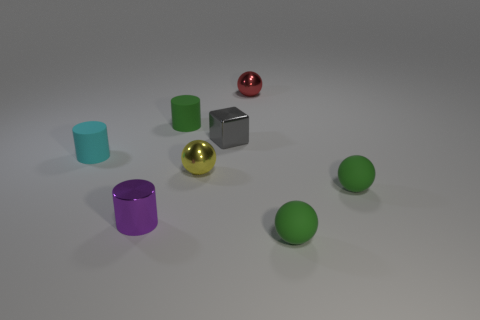Add 1 small cylinders. How many objects exist? 9 Subtract all cubes. How many objects are left? 7 Add 7 gray cubes. How many gray cubes are left? 8 Add 6 tiny yellow rubber spheres. How many tiny yellow rubber spheres exist? 6 Subtract 1 red spheres. How many objects are left? 7 Subtract all tiny matte cylinders. Subtract all tiny gray cubes. How many objects are left? 5 